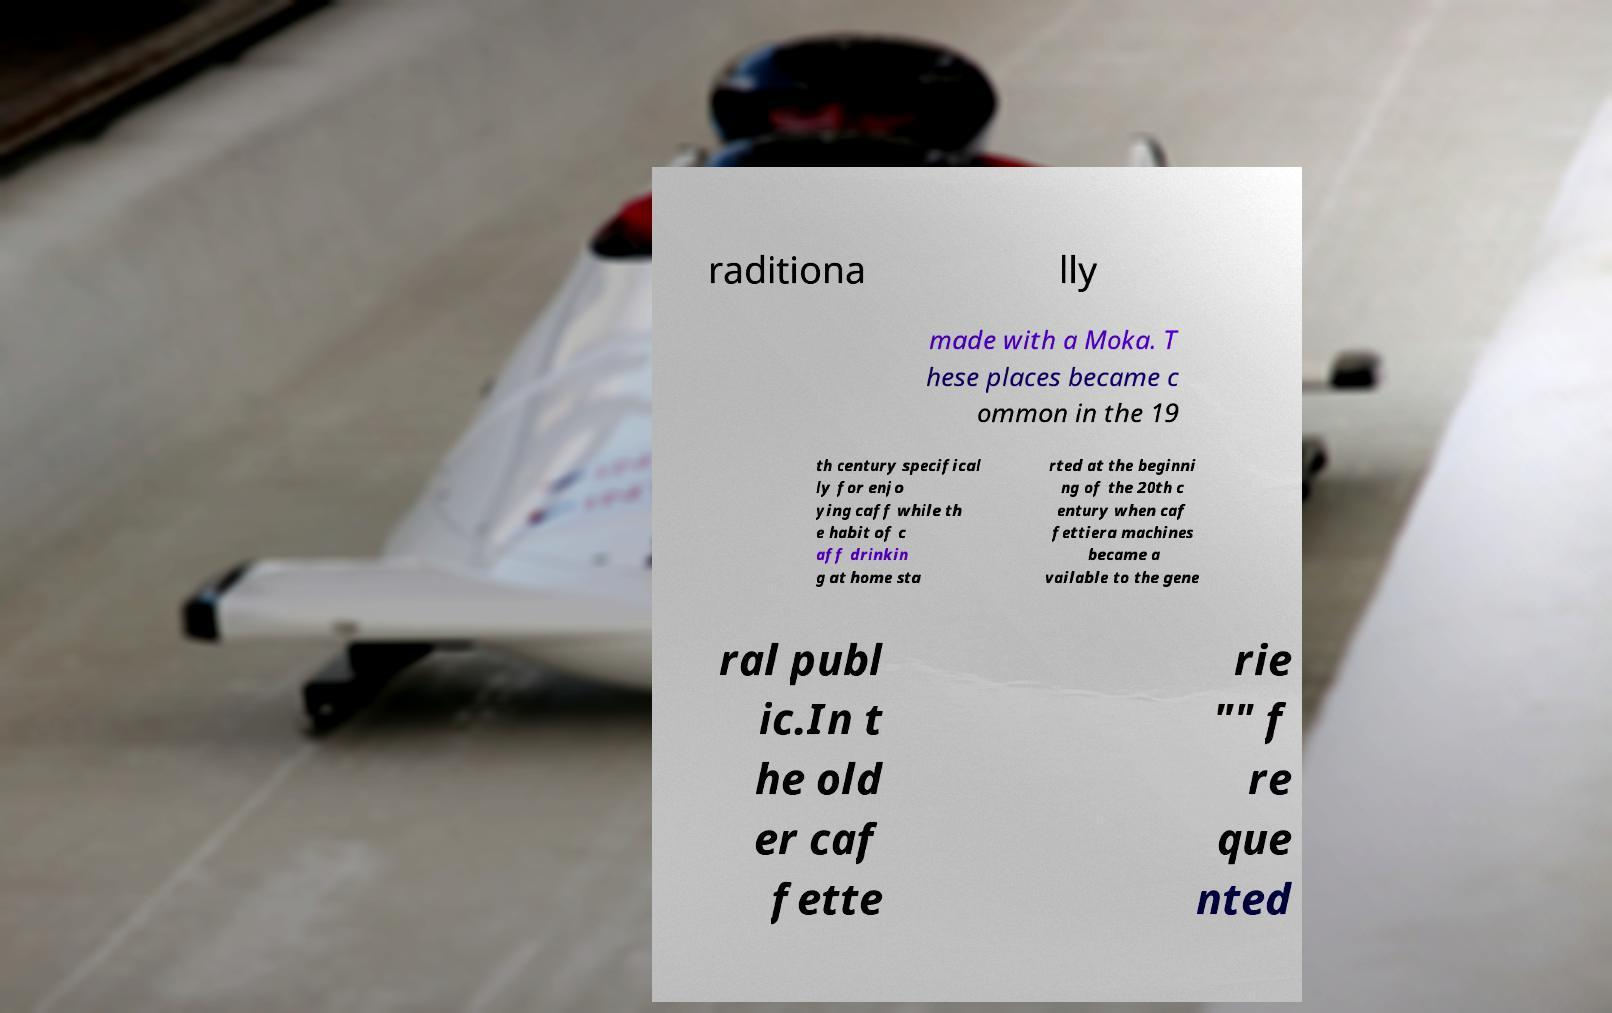Can you read and provide the text displayed in the image?This photo seems to have some interesting text. Can you extract and type it out for me? raditiona lly made with a Moka. T hese places became c ommon in the 19 th century specifical ly for enjo ying caff while th e habit of c aff drinkin g at home sta rted at the beginni ng of the 20th c entury when caf fettiera machines became a vailable to the gene ral publ ic.In t he old er caf fette rie "" f re que nted 